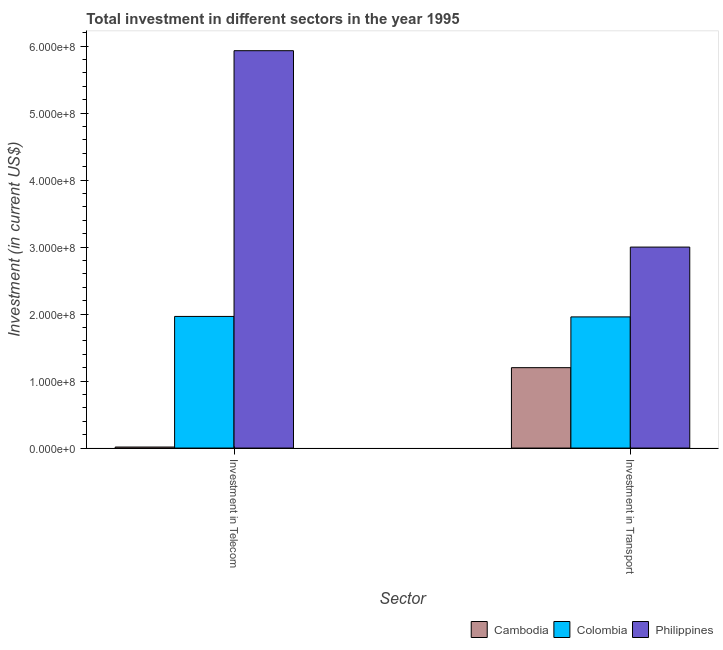How many groups of bars are there?
Ensure brevity in your answer.  2. Are the number of bars on each tick of the X-axis equal?
Provide a short and direct response. Yes. How many bars are there on the 2nd tick from the left?
Your answer should be very brief. 3. What is the label of the 1st group of bars from the left?
Your answer should be very brief. Investment in Telecom. What is the investment in telecom in Philippines?
Offer a very short reply. 5.93e+08. Across all countries, what is the maximum investment in transport?
Give a very brief answer. 3.00e+08. Across all countries, what is the minimum investment in transport?
Ensure brevity in your answer.  1.20e+08. In which country was the investment in telecom maximum?
Give a very brief answer. Philippines. In which country was the investment in transport minimum?
Ensure brevity in your answer.  Cambodia. What is the total investment in transport in the graph?
Make the answer very short. 6.16e+08. What is the difference between the investment in telecom in Cambodia and that in Philippines?
Your answer should be compact. -5.92e+08. What is the difference between the investment in transport in Philippines and the investment in telecom in Cambodia?
Provide a short and direct response. 2.98e+08. What is the average investment in transport per country?
Your answer should be very brief. 2.05e+08. What is the difference between the investment in transport and investment in telecom in Cambodia?
Keep it short and to the point. 1.18e+08. What is the ratio of the investment in telecom in Philippines to that in Colombia?
Ensure brevity in your answer.  3.02. Is the investment in transport in Cambodia less than that in Philippines?
Offer a very short reply. Yes. What does the 1st bar from the right in Investment in Telecom represents?
Keep it short and to the point. Philippines. How many bars are there?
Provide a succinct answer. 6. How many countries are there in the graph?
Provide a succinct answer. 3. What is the difference between two consecutive major ticks on the Y-axis?
Give a very brief answer. 1.00e+08. Are the values on the major ticks of Y-axis written in scientific E-notation?
Your response must be concise. Yes. Does the graph contain any zero values?
Offer a terse response. No. Where does the legend appear in the graph?
Offer a terse response. Bottom right. How many legend labels are there?
Your answer should be very brief. 3. How are the legend labels stacked?
Offer a terse response. Horizontal. What is the title of the graph?
Provide a succinct answer. Total investment in different sectors in the year 1995. What is the label or title of the X-axis?
Offer a terse response. Sector. What is the label or title of the Y-axis?
Provide a succinct answer. Investment (in current US$). What is the Investment (in current US$) of Cambodia in Investment in Telecom?
Offer a terse response. 1.50e+06. What is the Investment (in current US$) of Colombia in Investment in Telecom?
Offer a very short reply. 1.96e+08. What is the Investment (in current US$) of Philippines in Investment in Telecom?
Make the answer very short. 5.93e+08. What is the Investment (in current US$) in Cambodia in Investment in Transport?
Offer a very short reply. 1.20e+08. What is the Investment (in current US$) of Colombia in Investment in Transport?
Keep it short and to the point. 1.96e+08. What is the Investment (in current US$) of Philippines in Investment in Transport?
Your response must be concise. 3.00e+08. Across all Sector, what is the maximum Investment (in current US$) in Cambodia?
Your answer should be very brief. 1.20e+08. Across all Sector, what is the maximum Investment (in current US$) in Colombia?
Your answer should be compact. 1.96e+08. Across all Sector, what is the maximum Investment (in current US$) of Philippines?
Provide a short and direct response. 5.93e+08. Across all Sector, what is the minimum Investment (in current US$) of Cambodia?
Your answer should be very brief. 1.50e+06. Across all Sector, what is the minimum Investment (in current US$) of Colombia?
Provide a succinct answer. 1.96e+08. Across all Sector, what is the minimum Investment (in current US$) in Philippines?
Make the answer very short. 3.00e+08. What is the total Investment (in current US$) in Cambodia in the graph?
Your answer should be very brief. 1.22e+08. What is the total Investment (in current US$) in Colombia in the graph?
Offer a terse response. 3.92e+08. What is the total Investment (in current US$) of Philippines in the graph?
Your answer should be compact. 8.93e+08. What is the difference between the Investment (in current US$) in Cambodia in Investment in Telecom and that in Investment in Transport?
Your answer should be compact. -1.18e+08. What is the difference between the Investment (in current US$) of Colombia in Investment in Telecom and that in Investment in Transport?
Your answer should be compact. 7.00e+05. What is the difference between the Investment (in current US$) of Philippines in Investment in Telecom and that in Investment in Transport?
Provide a succinct answer. 2.93e+08. What is the difference between the Investment (in current US$) in Cambodia in Investment in Telecom and the Investment (in current US$) in Colombia in Investment in Transport?
Your answer should be compact. -1.94e+08. What is the difference between the Investment (in current US$) of Cambodia in Investment in Telecom and the Investment (in current US$) of Philippines in Investment in Transport?
Make the answer very short. -2.98e+08. What is the difference between the Investment (in current US$) in Colombia in Investment in Telecom and the Investment (in current US$) in Philippines in Investment in Transport?
Your answer should be very brief. -1.04e+08. What is the average Investment (in current US$) in Cambodia per Sector?
Offer a terse response. 6.08e+07. What is the average Investment (in current US$) of Colombia per Sector?
Your answer should be very brief. 1.96e+08. What is the average Investment (in current US$) of Philippines per Sector?
Make the answer very short. 4.47e+08. What is the difference between the Investment (in current US$) of Cambodia and Investment (in current US$) of Colombia in Investment in Telecom?
Give a very brief answer. -1.95e+08. What is the difference between the Investment (in current US$) in Cambodia and Investment (in current US$) in Philippines in Investment in Telecom?
Provide a short and direct response. -5.92e+08. What is the difference between the Investment (in current US$) of Colombia and Investment (in current US$) of Philippines in Investment in Telecom?
Offer a very short reply. -3.97e+08. What is the difference between the Investment (in current US$) of Cambodia and Investment (in current US$) of Colombia in Investment in Transport?
Your answer should be very brief. -7.58e+07. What is the difference between the Investment (in current US$) of Cambodia and Investment (in current US$) of Philippines in Investment in Transport?
Offer a very short reply. -1.80e+08. What is the difference between the Investment (in current US$) of Colombia and Investment (in current US$) of Philippines in Investment in Transport?
Keep it short and to the point. -1.04e+08. What is the ratio of the Investment (in current US$) of Cambodia in Investment in Telecom to that in Investment in Transport?
Provide a short and direct response. 0.01. What is the ratio of the Investment (in current US$) in Philippines in Investment in Telecom to that in Investment in Transport?
Ensure brevity in your answer.  1.98. What is the difference between the highest and the second highest Investment (in current US$) in Cambodia?
Provide a succinct answer. 1.18e+08. What is the difference between the highest and the second highest Investment (in current US$) of Philippines?
Keep it short and to the point. 2.93e+08. What is the difference between the highest and the lowest Investment (in current US$) of Cambodia?
Offer a terse response. 1.18e+08. What is the difference between the highest and the lowest Investment (in current US$) in Philippines?
Keep it short and to the point. 2.93e+08. 